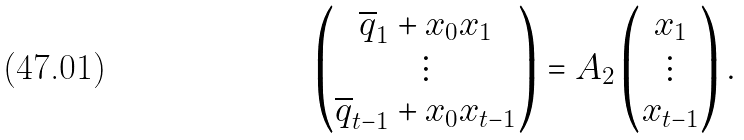Convert formula to latex. <formula><loc_0><loc_0><loc_500><loc_500>\left ( \begin{matrix} \overline { q } _ { 1 } + x _ { 0 } x _ { 1 } \\ \vdots \\ \overline { q } _ { t - 1 } + x _ { 0 } x _ { t - 1 } \end{matrix} \right ) = A _ { 2 } \left ( \begin{matrix} x _ { 1 } \\ \vdots \\ x _ { t - 1 } \end{matrix} \right ) .</formula> 